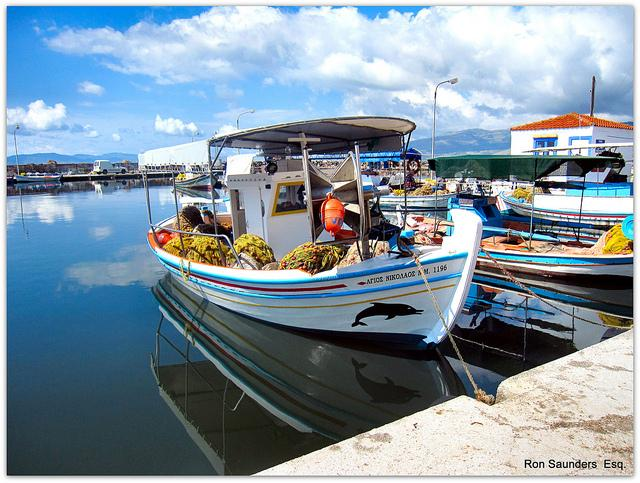What yellow items sits on the boat? nets 